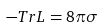<formula> <loc_0><loc_0><loc_500><loc_500>- T r L = 8 \pi \sigma</formula> 